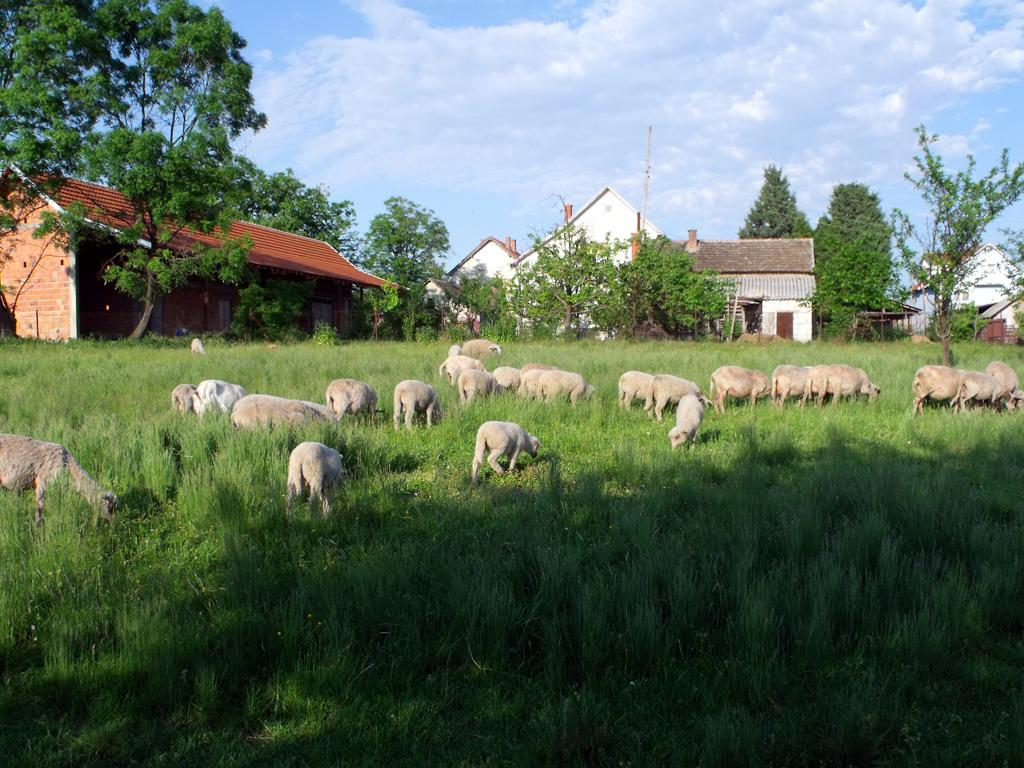What is located in the center of the image? There are animals in the center of the image. What type of terrain is visible at the bottom of the image? There is grass at the bottom of the image. What structures can be seen in the background of the image? There are houses and trees in the background of the image. What part of the natural environment is visible at the top of the image? The sky is visible at the top of the image. What type of disgust can be seen on the animals' faces in the image? There is no indication of disgust on the animals' faces in the image; they appear to be neutral or content. 